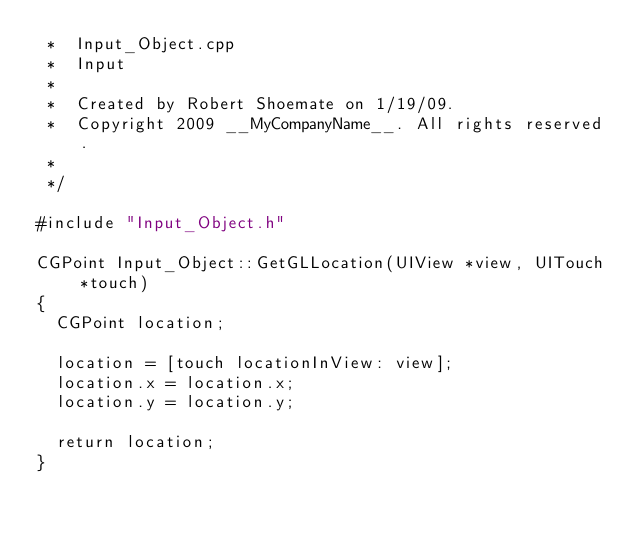Convert code to text. <code><loc_0><loc_0><loc_500><loc_500><_ObjectiveC_> *  Input_Object.cpp
 *  Input
 *
 *  Created by Robert Shoemate on 1/19/09.
 *  Copyright 2009 __MyCompanyName__. All rights reserved.
 *
 */

#include "Input_Object.h"

CGPoint Input_Object::GetGLLocation(UIView *view, UITouch *touch)
{
	CGPoint location;
	
	location = [touch locationInView: view];
	location.x = location.x;
	location.y = location.y;
	
	return location;
}</code> 